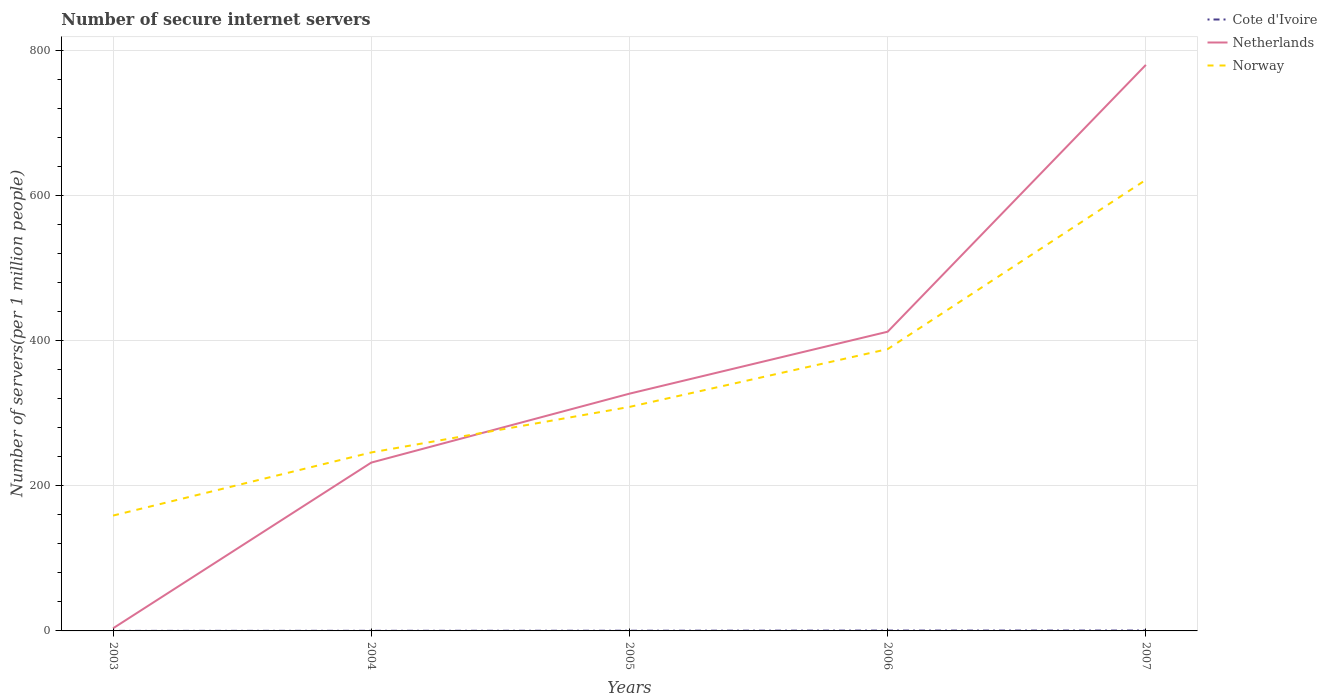Does the line corresponding to Norway intersect with the line corresponding to Cote d'Ivoire?
Offer a very short reply. No. Is the number of lines equal to the number of legend labels?
Keep it short and to the point. Yes. Across all years, what is the maximum number of secure internet servers in Norway?
Your response must be concise. 159.04. What is the total number of secure internet servers in Cote d'Ivoire in the graph?
Your answer should be compact. -0.36. What is the difference between the highest and the second highest number of secure internet servers in Cote d'Ivoire?
Your answer should be very brief. 0.47. What is the difference between the highest and the lowest number of secure internet servers in Cote d'Ivoire?
Your answer should be compact. 2. Is the number of secure internet servers in Cote d'Ivoire strictly greater than the number of secure internet servers in Netherlands over the years?
Your answer should be very brief. Yes. How many years are there in the graph?
Your answer should be compact. 5. Are the values on the major ticks of Y-axis written in scientific E-notation?
Give a very brief answer. No. Does the graph contain any zero values?
Your answer should be very brief. No. Does the graph contain grids?
Provide a short and direct response. Yes. How many legend labels are there?
Your response must be concise. 3. How are the legend labels stacked?
Make the answer very short. Vertical. What is the title of the graph?
Provide a short and direct response. Number of secure internet servers. Does "Estonia" appear as one of the legend labels in the graph?
Offer a terse response. No. What is the label or title of the X-axis?
Make the answer very short. Years. What is the label or title of the Y-axis?
Give a very brief answer. Number of servers(per 1 million people). What is the Number of servers(per 1 million people) in Cote d'Ivoire in 2003?
Your answer should be very brief. 0.06. What is the Number of servers(per 1 million people) in Netherlands in 2003?
Offer a terse response. 3.57. What is the Number of servers(per 1 million people) in Norway in 2003?
Offer a very short reply. 159.04. What is the Number of servers(per 1 million people) of Cote d'Ivoire in 2004?
Keep it short and to the point. 0.17. What is the Number of servers(per 1 million people) in Netherlands in 2004?
Make the answer very short. 232.1. What is the Number of servers(per 1 million people) in Norway in 2004?
Offer a terse response. 246.08. What is the Number of servers(per 1 million people) in Cote d'Ivoire in 2005?
Give a very brief answer. 0.28. What is the Number of servers(per 1 million people) in Netherlands in 2005?
Offer a very short reply. 327.15. What is the Number of servers(per 1 million people) in Norway in 2005?
Give a very brief answer. 308.87. What is the Number of servers(per 1 million people) of Cote d'Ivoire in 2006?
Give a very brief answer. 0.49. What is the Number of servers(per 1 million people) in Netherlands in 2006?
Give a very brief answer. 412.58. What is the Number of servers(per 1 million people) of Norway in 2006?
Offer a very short reply. 388.57. What is the Number of servers(per 1 million people) in Cote d'Ivoire in 2007?
Make the answer very short. 0.53. What is the Number of servers(per 1 million people) of Netherlands in 2007?
Make the answer very short. 780.51. What is the Number of servers(per 1 million people) in Norway in 2007?
Keep it short and to the point. 621.98. Across all years, what is the maximum Number of servers(per 1 million people) in Cote d'Ivoire?
Ensure brevity in your answer.  0.53. Across all years, what is the maximum Number of servers(per 1 million people) of Netherlands?
Provide a short and direct response. 780.51. Across all years, what is the maximum Number of servers(per 1 million people) of Norway?
Your answer should be very brief. 621.98. Across all years, what is the minimum Number of servers(per 1 million people) of Cote d'Ivoire?
Provide a short and direct response. 0.06. Across all years, what is the minimum Number of servers(per 1 million people) of Netherlands?
Provide a succinct answer. 3.57. Across all years, what is the minimum Number of servers(per 1 million people) in Norway?
Your answer should be very brief. 159.04. What is the total Number of servers(per 1 million people) of Cote d'Ivoire in the graph?
Keep it short and to the point. 1.52. What is the total Number of servers(per 1 million people) of Netherlands in the graph?
Make the answer very short. 1755.9. What is the total Number of servers(per 1 million people) in Norway in the graph?
Give a very brief answer. 1724.55. What is the difference between the Number of servers(per 1 million people) of Cote d'Ivoire in 2003 and that in 2004?
Your answer should be compact. -0.11. What is the difference between the Number of servers(per 1 million people) of Netherlands in 2003 and that in 2004?
Provide a short and direct response. -228.53. What is the difference between the Number of servers(per 1 million people) of Norway in 2003 and that in 2004?
Give a very brief answer. -87.04. What is the difference between the Number of servers(per 1 million people) in Cote d'Ivoire in 2003 and that in 2005?
Your response must be concise. -0.22. What is the difference between the Number of servers(per 1 million people) in Netherlands in 2003 and that in 2005?
Offer a terse response. -323.57. What is the difference between the Number of servers(per 1 million people) of Norway in 2003 and that in 2005?
Ensure brevity in your answer.  -149.83. What is the difference between the Number of servers(per 1 million people) in Cote d'Ivoire in 2003 and that in 2006?
Make the answer very short. -0.43. What is the difference between the Number of servers(per 1 million people) of Netherlands in 2003 and that in 2006?
Offer a terse response. -409. What is the difference between the Number of servers(per 1 million people) in Norway in 2003 and that in 2006?
Keep it short and to the point. -229.53. What is the difference between the Number of servers(per 1 million people) in Cote d'Ivoire in 2003 and that in 2007?
Your response must be concise. -0.47. What is the difference between the Number of servers(per 1 million people) of Netherlands in 2003 and that in 2007?
Your answer should be very brief. -776.93. What is the difference between the Number of servers(per 1 million people) of Norway in 2003 and that in 2007?
Provide a short and direct response. -462.94. What is the difference between the Number of servers(per 1 million people) in Cote d'Ivoire in 2004 and that in 2005?
Ensure brevity in your answer.  -0.11. What is the difference between the Number of servers(per 1 million people) in Netherlands in 2004 and that in 2005?
Offer a very short reply. -95.05. What is the difference between the Number of servers(per 1 million people) of Norway in 2004 and that in 2005?
Offer a very short reply. -62.79. What is the difference between the Number of servers(per 1 million people) of Cote d'Ivoire in 2004 and that in 2006?
Provide a succinct answer. -0.32. What is the difference between the Number of servers(per 1 million people) of Netherlands in 2004 and that in 2006?
Offer a terse response. -180.48. What is the difference between the Number of servers(per 1 million people) of Norway in 2004 and that in 2006?
Offer a very short reply. -142.49. What is the difference between the Number of servers(per 1 million people) in Cote d'Ivoire in 2004 and that in 2007?
Keep it short and to the point. -0.36. What is the difference between the Number of servers(per 1 million people) in Netherlands in 2004 and that in 2007?
Provide a succinct answer. -548.41. What is the difference between the Number of servers(per 1 million people) of Norway in 2004 and that in 2007?
Offer a terse response. -375.9. What is the difference between the Number of servers(per 1 million people) of Cote d'Ivoire in 2005 and that in 2006?
Provide a succinct answer. -0.21. What is the difference between the Number of servers(per 1 million people) in Netherlands in 2005 and that in 2006?
Keep it short and to the point. -85.43. What is the difference between the Number of servers(per 1 million people) in Norway in 2005 and that in 2006?
Offer a very short reply. -79.7. What is the difference between the Number of servers(per 1 million people) in Cote d'Ivoire in 2005 and that in 2007?
Provide a succinct answer. -0.25. What is the difference between the Number of servers(per 1 million people) of Netherlands in 2005 and that in 2007?
Your answer should be compact. -453.36. What is the difference between the Number of servers(per 1 million people) in Norway in 2005 and that in 2007?
Your answer should be compact. -313.11. What is the difference between the Number of servers(per 1 million people) in Cote d'Ivoire in 2006 and that in 2007?
Ensure brevity in your answer.  -0.04. What is the difference between the Number of servers(per 1 million people) in Netherlands in 2006 and that in 2007?
Provide a succinct answer. -367.93. What is the difference between the Number of servers(per 1 million people) in Norway in 2006 and that in 2007?
Make the answer very short. -233.41. What is the difference between the Number of servers(per 1 million people) of Cote d'Ivoire in 2003 and the Number of servers(per 1 million people) of Netherlands in 2004?
Offer a terse response. -232.04. What is the difference between the Number of servers(per 1 million people) of Cote d'Ivoire in 2003 and the Number of servers(per 1 million people) of Norway in 2004?
Give a very brief answer. -246.03. What is the difference between the Number of servers(per 1 million people) of Netherlands in 2003 and the Number of servers(per 1 million people) of Norway in 2004?
Give a very brief answer. -242.51. What is the difference between the Number of servers(per 1 million people) of Cote d'Ivoire in 2003 and the Number of servers(per 1 million people) of Netherlands in 2005?
Provide a short and direct response. -327.09. What is the difference between the Number of servers(per 1 million people) in Cote d'Ivoire in 2003 and the Number of servers(per 1 million people) in Norway in 2005?
Offer a terse response. -308.81. What is the difference between the Number of servers(per 1 million people) in Netherlands in 2003 and the Number of servers(per 1 million people) in Norway in 2005?
Provide a short and direct response. -305.3. What is the difference between the Number of servers(per 1 million people) of Cote d'Ivoire in 2003 and the Number of servers(per 1 million people) of Netherlands in 2006?
Keep it short and to the point. -412.52. What is the difference between the Number of servers(per 1 million people) in Cote d'Ivoire in 2003 and the Number of servers(per 1 million people) in Norway in 2006?
Keep it short and to the point. -388.51. What is the difference between the Number of servers(per 1 million people) of Netherlands in 2003 and the Number of servers(per 1 million people) of Norway in 2006?
Give a very brief answer. -385. What is the difference between the Number of servers(per 1 million people) of Cote d'Ivoire in 2003 and the Number of servers(per 1 million people) of Netherlands in 2007?
Your response must be concise. -780.45. What is the difference between the Number of servers(per 1 million people) of Cote d'Ivoire in 2003 and the Number of servers(per 1 million people) of Norway in 2007?
Your answer should be very brief. -621.92. What is the difference between the Number of servers(per 1 million people) in Netherlands in 2003 and the Number of servers(per 1 million people) in Norway in 2007?
Provide a succinct answer. -618.41. What is the difference between the Number of servers(per 1 million people) of Cote d'Ivoire in 2004 and the Number of servers(per 1 million people) of Netherlands in 2005?
Keep it short and to the point. -326.98. What is the difference between the Number of servers(per 1 million people) of Cote d'Ivoire in 2004 and the Number of servers(per 1 million people) of Norway in 2005?
Ensure brevity in your answer.  -308.7. What is the difference between the Number of servers(per 1 million people) in Netherlands in 2004 and the Number of servers(per 1 million people) in Norway in 2005?
Keep it short and to the point. -76.77. What is the difference between the Number of servers(per 1 million people) of Cote d'Ivoire in 2004 and the Number of servers(per 1 million people) of Netherlands in 2006?
Your answer should be compact. -412.41. What is the difference between the Number of servers(per 1 million people) in Cote d'Ivoire in 2004 and the Number of servers(per 1 million people) in Norway in 2006?
Your answer should be compact. -388.4. What is the difference between the Number of servers(per 1 million people) of Netherlands in 2004 and the Number of servers(per 1 million people) of Norway in 2006?
Offer a very short reply. -156.47. What is the difference between the Number of servers(per 1 million people) of Cote d'Ivoire in 2004 and the Number of servers(per 1 million people) of Netherlands in 2007?
Offer a very short reply. -780.34. What is the difference between the Number of servers(per 1 million people) in Cote d'Ivoire in 2004 and the Number of servers(per 1 million people) in Norway in 2007?
Offer a terse response. -621.81. What is the difference between the Number of servers(per 1 million people) of Netherlands in 2004 and the Number of servers(per 1 million people) of Norway in 2007?
Your response must be concise. -389.88. What is the difference between the Number of servers(per 1 million people) of Cote d'Ivoire in 2005 and the Number of servers(per 1 million people) of Netherlands in 2006?
Keep it short and to the point. -412.3. What is the difference between the Number of servers(per 1 million people) of Cote d'Ivoire in 2005 and the Number of servers(per 1 million people) of Norway in 2006?
Your answer should be compact. -388.29. What is the difference between the Number of servers(per 1 million people) of Netherlands in 2005 and the Number of servers(per 1 million people) of Norway in 2006?
Provide a succinct answer. -61.42. What is the difference between the Number of servers(per 1 million people) in Cote d'Ivoire in 2005 and the Number of servers(per 1 million people) in Netherlands in 2007?
Provide a short and direct response. -780.23. What is the difference between the Number of servers(per 1 million people) of Cote d'Ivoire in 2005 and the Number of servers(per 1 million people) of Norway in 2007?
Ensure brevity in your answer.  -621.7. What is the difference between the Number of servers(per 1 million people) in Netherlands in 2005 and the Number of servers(per 1 million people) in Norway in 2007?
Make the answer very short. -294.83. What is the difference between the Number of servers(per 1 million people) of Cote d'Ivoire in 2006 and the Number of servers(per 1 million people) of Netherlands in 2007?
Ensure brevity in your answer.  -780.02. What is the difference between the Number of servers(per 1 million people) in Cote d'Ivoire in 2006 and the Number of servers(per 1 million people) in Norway in 2007?
Make the answer very short. -621.49. What is the difference between the Number of servers(per 1 million people) of Netherlands in 2006 and the Number of servers(per 1 million people) of Norway in 2007?
Offer a very short reply. -209.4. What is the average Number of servers(per 1 million people) of Cote d'Ivoire per year?
Your answer should be compact. 0.3. What is the average Number of servers(per 1 million people) of Netherlands per year?
Keep it short and to the point. 351.18. What is the average Number of servers(per 1 million people) in Norway per year?
Your answer should be very brief. 344.91. In the year 2003, what is the difference between the Number of servers(per 1 million people) of Cote d'Ivoire and Number of servers(per 1 million people) of Netherlands?
Make the answer very short. -3.52. In the year 2003, what is the difference between the Number of servers(per 1 million people) in Cote d'Ivoire and Number of servers(per 1 million people) in Norway?
Provide a short and direct response. -158.98. In the year 2003, what is the difference between the Number of servers(per 1 million people) in Netherlands and Number of servers(per 1 million people) in Norway?
Make the answer very short. -155.47. In the year 2004, what is the difference between the Number of servers(per 1 million people) of Cote d'Ivoire and Number of servers(per 1 million people) of Netherlands?
Your answer should be very brief. -231.93. In the year 2004, what is the difference between the Number of servers(per 1 million people) in Cote d'Ivoire and Number of servers(per 1 million people) in Norway?
Offer a terse response. -245.92. In the year 2004, what is the difference between the Number of servers(per 1 million people) of Netherlands and Number of servers(per 1 million people) of Norway?
Your response must be concise. -13.98. In the year 2005, what is the difference between the Number of servers(per 1 million people) in Cote d'Ivoire and Number of servers(per 1 million people) in Netherlands?
Make the answer very short. -326.87. In the year 2005, what is the difference between the Number of servers(per 1 million people) in Cote d'Ivoire and Number of servers(per 1 million people) in Norway?
Offer a terse response. -308.6. In the year 2005, what is the difference between the Number of servers(per 1 million people) in Netherlands and Number of servers(per 1 million people) in Norway?
Ensure brevity in your answer.  18.28. In the year 2006, what is the difference between the Number of servers(per 1 million people) of Cote d'Ivoire and Number of servers(per 1 million people) of Netherlands?
Offer a terse response. -412.09. In the year 2006, what is the difference between the Number of servers(per 1 million people) in Cote d'Ivoire and Number of servers(per 1 million people) in Norway?
Make the answer very short. -388.08. In the year 2006, what is the difference between the Number of servers(per 1 million people) of Netherlands and Number of servers(per 1 million people) of Norway?
Offer a terse response. 24.01. In the year 2007, what is the difference between the Number of servers(per 1 million people) in Cote d'Ivoire and Number of servers(per 1 million people) in Netherlands?
Provide a short and direct response. -779.98. In the year 2007, what is the difference between the Number of servers(per 1 million people) of Cote d'Ivoire and Number of servers(per 1 million people) of Norway?
Ensure brevity in your answer.  -621.45. In the year 2007, what is the difference between the Number of servers(per 1 million people) of Netherlands and Number of servers(per 1 million people) of Norway?
Your answer should be compact. 158.53. What is the ratio of the Number of servers(per 1 million people) of Cote d'Ivoire in 2003 to that in 2004?
Provide a short and direct response. 0.34. What is the ratio of the Number of servers(per 1 million people) in Netherlands in 2003 to that in 2004?
Offer a terse response. 0.02. What is the ratio of the Number of servers(per 1 million people) in Norway in 2003 to that in 2004?
Offer a very short reply. 0.65. What is the ratio of the Number of servers(per 1 million people) in Cote d'Ivoire in 2003 to that in 2005?
Ensure brevity in your answer.  0.21. What is the ratio of the Number of servers(per 1 million people) in Netherlands in 2003 to that in 2005?
Make the answer very short. 0.01. What is the ratio of the Number of servers(per 1 million people) in Norway in 2003 to that in 2005?
Give a very brief answer. 0.51. What is the ratio of the Number of servers(per 1 million people) of Cote d'Ivoire in 2003 to that in 2006?
Your answer should be very brief. 0.12. What is the ratio of the Number of servers(per 1 million people) of Netherlands in 2003 to that in 2006?
Give a very brief answer. 0.01. What is the ratio of the Number of servers(per 1 million people) in Norway in 2003 to that in 2006?
Your answer should be compact. 0.41. What is the ratio of the Number of servers(per 1 million people) in Cote d'Ivoire in 2003 to that in 2007?
Your answer should be very brief. 0.11. What is the ratio of the Number of servers(per 1 million people) of Netherlands in 2003 to that in 2007?
Provide a succinct answer. 0. What is the ratio of the Number of servers(per 1 million people) in Norway in 2003 to that in 2007?
Your answer should be compact. 0.26. What is the ratio of the Number of servers(per 1 million people) in Cote d'Ivoire in 2004 to that in 2005?
Your answer should be compact. 0.61. What is the ratio of the Number of servers(per 1 million people) of Netherlands in 2004 to that in 2005?
Keep it short and to the point. 0.71. What is the ratio of the Number of servers(per 1 million people) of Norway in 2004 to that in 2005?
Offer a very short reply. 0.8. What is the ratio of the Number of servers(per 1 million people) in Cote d'Ivoire in 2004 to that in 2006?
Provide a short and direct response. 0.35. What is the ratio of the Number of servers(per 1 million people) of Netherlands in 2004 to that in 2006?
Keep it short and to the point. 0.56. What is the ratio of the Number of servers(per 1 million people) of Norway in 2004 to that in 2006?
Your response must be concise. 0.63. What is the ratio of the Number of servers(per 1 million people) in Cote d'Ivoire in 2004 to that in 2007?
Keep it short and to the point. 0.32. What is the ratio of the Number of servers(per 1 million people) in Netherlands in 2004 to that in 2007?
Keep it short and to the point. 0.3. What is the ratio of the Number of servers(per 1 million people) of Norway in 2004 to that in 2007?
Offer a very short reply. 0.4. What is the ratio of the Number of servers(per 1 million people) in Cote d'Ivoire in 2005 to that in 2006?
Provide a succinct answer. 0.57. What is the ratio of the Number of servers(per 1 million people) in Netherlands in 2005 to that in 2006?
Your answer should be very brief. 0.79. What is the ratio of the Number of servers(per 1 million people) in Norway in 2005 to that in 2006?
Your answer should be compact. 0.79. What is the ratio of the Number of servers(per 1 million people) of Cote d'Ivoire in 2005 to that in 2007?
Provide a short and direct response. 0.52. What is the ratio of the Number of servers(per 1 million people) of Netherlands in 2005 to that in 2007?
Offer a terse response. 0.42. What is the ratio of the Number of servers(per 1 million people) in Norway in 2005 to that in 2007?
Give a very brief answer. 0.5. What is the ratio of the Number of servers(per 1 million people) of Cote d'Ivoire in 2006 to that in 2007?
Your answer should be compact. 0.92. What is the ratio of the Number of servers(per 1 million people) of Netherlands in 2006 to that in 2007?
Your response must be concise. 0.53. What is the ratio of the Number of servers(per 1 million people) in Norway in 2006 to that in 2007?
Make the answer very short. 0.62. What is the difference between the highest and the second highest Number of servers(per 1 million people) of Cote d'Ivoire?
Keep it short and to the point. 0.04. What is the difference between the highest and the second highest Number of servers(per 1 million people) of Netherlands?
Ensure brevity in your answer.  367.93. What is the difference between the highest and the second highest Number of servers(per 1 million people) of Norway?
Offer a very short reply. 233.41. What is the difference between the highest and the lowest Number of servers(per 1 million people) of Cote d'Ivoire?
Keep it short and to the point. 0.47. What is the difference between the highest and the lowest Number of servers(per 1 million people) in Netherlands?
Your response must be concise. 776.93. What is the difference between the highest and the lowest Number of servers(per 1 million people) of Norway?
Your response must be concise. 462.94. 